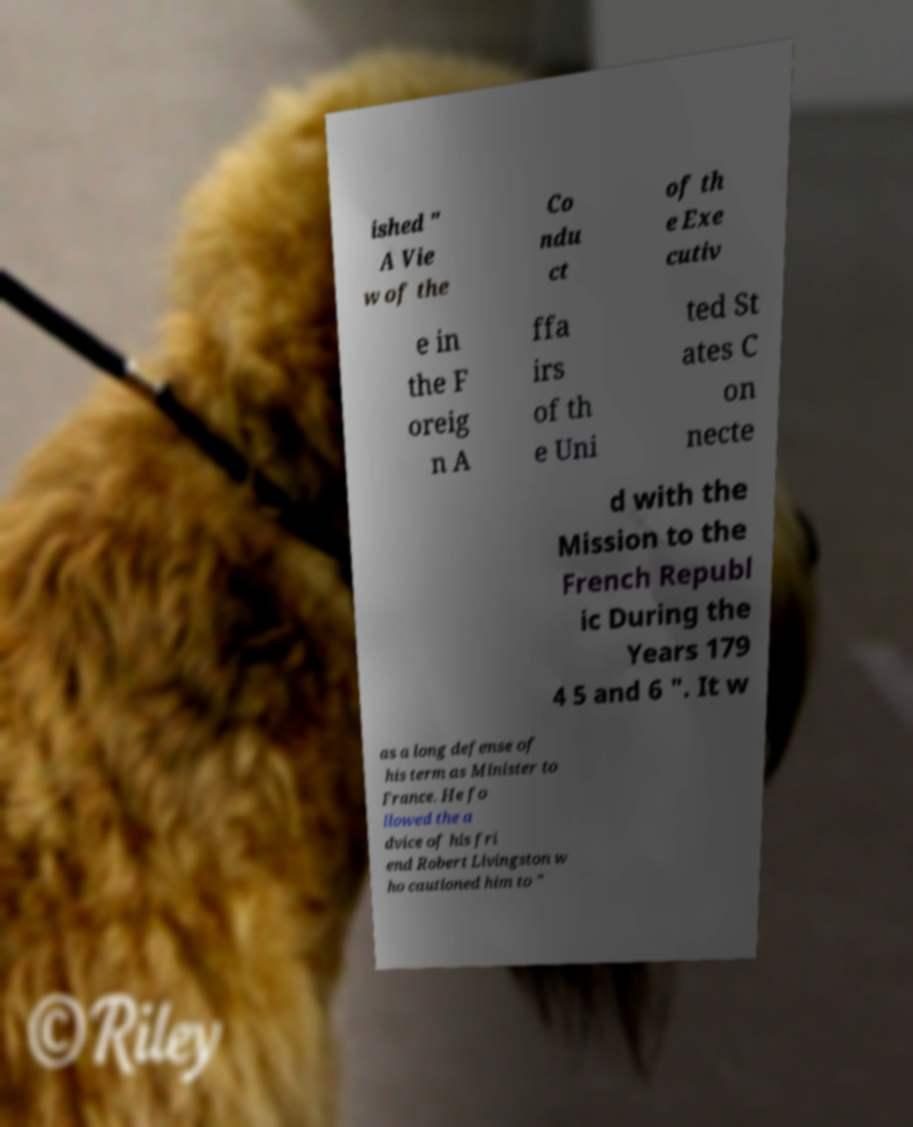There's text embedded in this image that I need extracted. Can you transcribe it verbatim? ished " A Vie w of the Co ndu ct of th e Exe cutiv e in the F oreig n A ffa irs of th e Uni ted St ates C on necte d with the Mission to the French Republ ic During the Years 179 4 5 and 6 ". It w as a long defense of his term as Minister to France. He fo llowed the a dvice of his fri end Robert Livingston w ho cautioned him to " 